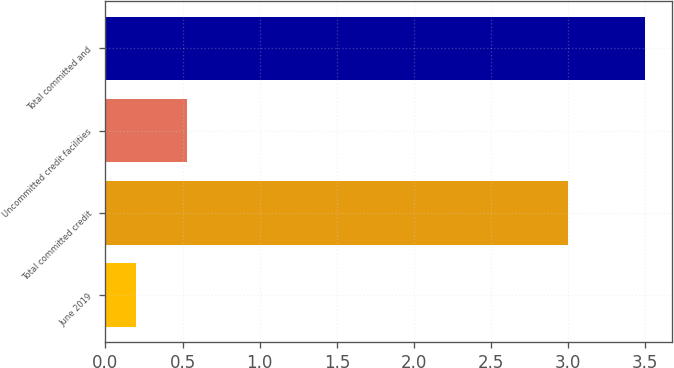<chart> <loc_0><loc_0><loc_500><loc_500><bar_chart><fcel>June 2019<fcel>Total committed credit<fcel>Uncommitted credit facilities<fcel>Total committed and<nl><fcel>0.2<fcel>3<fcel>0.53<fcel>3.5<nl></chart> 